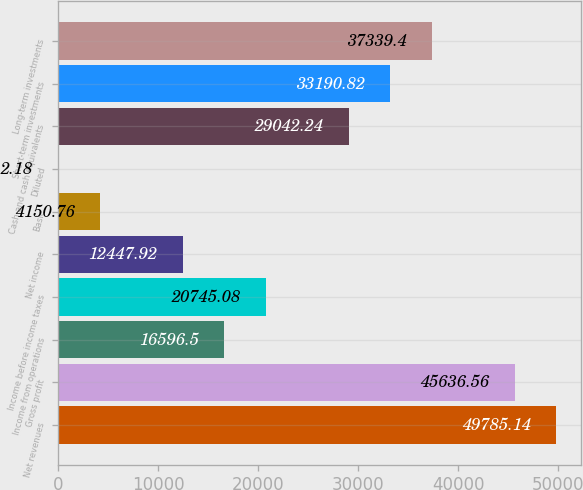Convert chart to OTSL. <chart><loc_0><loc_0><loc_500><loc_500><bar_chart><fcel>Net revenues<fcel>Gross profit<fcel>Income from operations<fcel>Income before income taxes<fcel>Net income<fcel>Basic<fcel>Diluted<fcel>Cash and cash equivalents<fcel>Short-term investments<fcel>Long-term investments<nl><fcel>49785.1<fcel>45636.6<fcel>16596.5<fcel>20745.1<fcel>12447.9<fcel>4150.76<fcel>2.18<fcel>29042.2<fcel>33190.8<fcel>37339.4<nl></chart> 